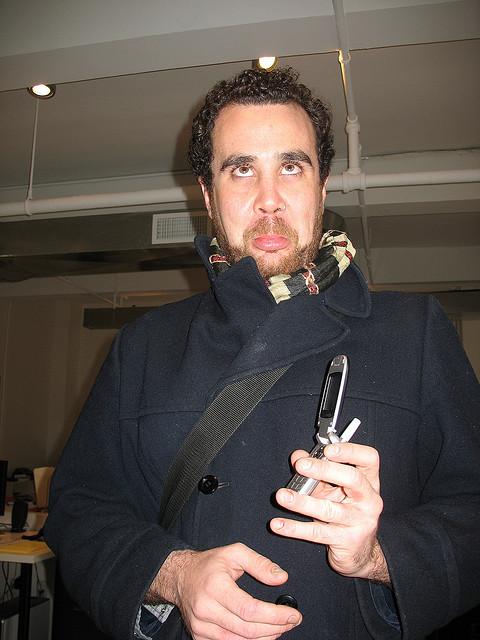Is the man making a funny face?
Quick response, please. Yes. Is the man wearing a winter coat?
Quick response, please. Yes. Is this man alive?
Answer briefly. Yes. 